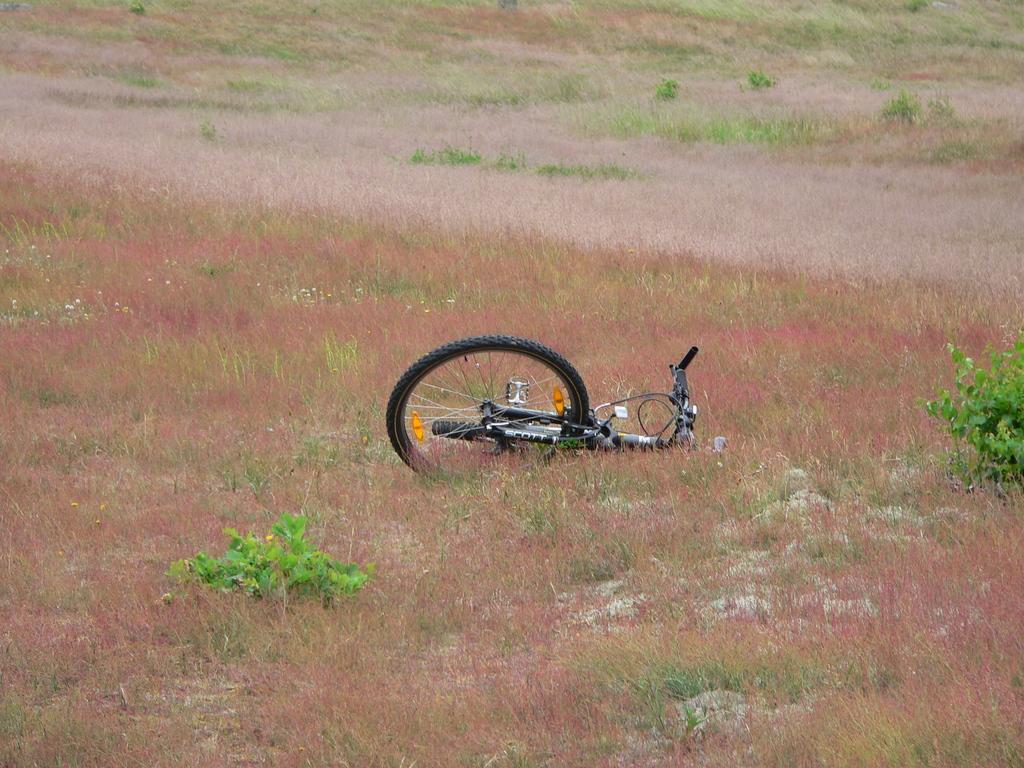How would you summarize this image in a sentence or two? In this image, this looks like a bicycle, which is lying on the ground. This is the grass. I can see the small plants. 